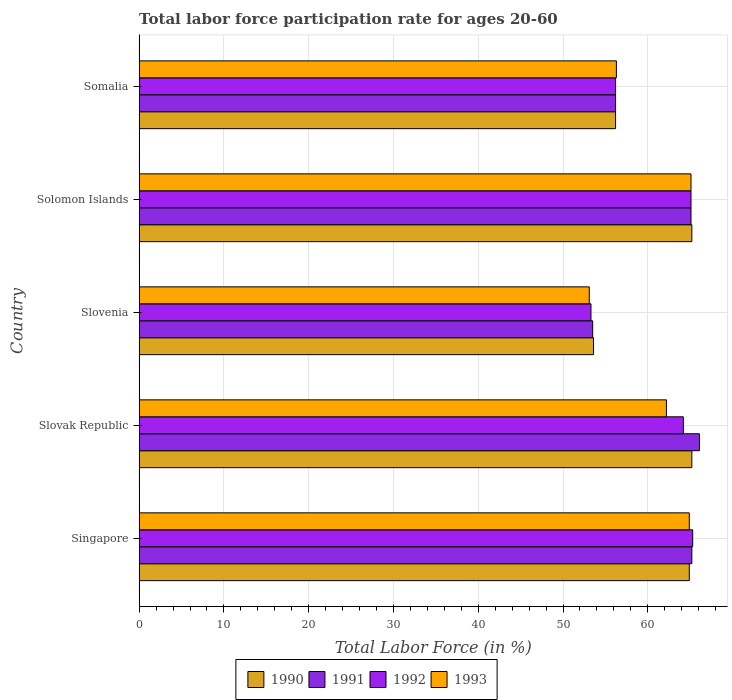How many different coloured bars are there?
Offer a terse response. 4. How many groups of bars are there?
Your answer should be compact. 5. Are the number of bars on each tick of the Y-axis equal?
Offer a terse response. Yes. How many bars are there on the 3rd tick from the top?
Ensure brevity in your answer.  4. How many bars are there on the 2nd tick from the bottom?
Make the answer very short. 4. What is the label of the 3rd group of bars from the top?
Your answer should be compact. Slovenia. What is the labor force participation rate in 1992 in Slovenia?
Ensure brevity in your answer.  53.3. Across all countries, what is the maximum labor force participation rate in 1992?
Keep it short and to the point. 65.3. Across all countries, what is the minimum labor force participation rate in 1991?
Offer a very short reply. 53.5. In which country was the labor force participation rate in 1990 maximum?
Provide a succinct answer. Slovak Republic. In which country was the labor force participation rate in 1992 minimum?
Your answer should be compact. Slovenia. What is the total labor force participation rate in 1993 in the graph?
Your answer should be compact. 301.6. What is the difference between the labor force participation rate in 1990 in Slovenia and that in Somalia?
Your response must be concise. -2.6. What is the difference between the labor force participation rate in 1990 in Slovenia and the labor force participation rate in 1993 in Singapore?
Offer a very short reply. -11.3. What is the average labor force participation rate in 1991 per country?
Your answer should be compact. 61.22. What is the difference between the labor force participation rate in 1990 and labor force participation rate in 1992 in Solomon Islands?
Give a very brief answer. 0.1. In how many countries, is the labor force participation rate in 1991 greater than 22 %?
Give a very brief answer. 5. What is the ratio of the labor force participation rate in 1991 in Slovenia to that in Somalia?
Your response must be concise. 0.95. Is the difference between the labor force participation rate in 1990 in Singapore and Slovenia greater than the difference between the labor force participation rate in 1992 in Singapore and Slovenia?
Provide a succinct answer. No. What is the difference between the highest and the second highest labor force participation rate in 1992?
Provide a succinct answer. 0.2. What is the difference between the highest and the lowest labor force participation rate in 1991?
Your response must be concise. 12.6. Is it the case that in every country, the sum of the labor force participation rate in 1993 and labor force participation rate in 1991 is greater than the labor force participation rate in 1990?
Ensure brevity in your answer.  Yes. How many bars are there?
Offer a terse response. 20. How many countries are there in the graph?
Ensure brevity in your answer.  5. Does the graph contain grids?
Keep it short and to the point. Yes. How are the legend labels stacked?
Your answer should be very brief. Horizontal. What is the title of the graph?
Offer a very short reply. Total labor force participation rate for ages 20-60. What is the label or title of the X-axis?
Offer a terse response. Total Labor Force (in %). What is the Total Labor Force (in %) in 1990 in Singapore?
Offer a very short reply. 64.9. What is the Total Labor Force (in %) of 1991 in Singapore?
Your response must be concise. 65.2. What is the Total Labor Force (in %) of 1992 in Singapore?
Provide a succinct answer. 65.3. What is the Total Labor Force (in %) of 1993 in Singapore?
Keep it short and to the point. 64.9. What is the Total Labor Force (in %) of 1990 in Slovak Republic?
Your response must be concise. 65.2. What is the Total Labor Force (in %) in 1991 in Slovak Republic?
Make the answer very short. 66.1. What is the Total Labor Force (in %) of 1992 in Slovak Republic?
Offer a terse response. 64.2. What is the Total Labor Force (in %) of 1993 in Slovak Republic?
Your answer should be very brief. 62.2. What is the Total Labor Force (in %) in 1990 in Slovenia?
Keep it short and to the point. 53.6. What is the Total Labor Force (in %) in 1991 in Slovenia?
Offer a terse response. 53.5. What is the Total Labor Force (in %) of 1992 in Slovenia?
Provide a succinct answer. 53.3. What is the Total Labor Force (in %) of 1993 in Slovenia?
Make the answer very short. 53.1. What is the Total Labor Force (in %) in 1990 in Solomon Islands?
Offer a terse response. 65.2. What is the Total Labor Force (in %) in 1991 in Solomon Islands?
Ensure brevity in your answer.  65.1. What is the Total Labor Force (in %) of 1992 in Solomon Islands?
Provide a succinct answer. 65.1. What is the Total Labor Force (in %) of 1993 in Solomon Islands?
Make the answer very short. 65.1. What is the Total Labor Force (in %) of 1990 in Somalia?
Keep it short and to the point. 56.2. What is the Total Labor Force (in %) of 1991 in Somalia?
Your answer should be very brief. 56.2. What is the Total Labor Force (in %) in 1992 in Somalia?
Your answer should be compact. 56.2. What is the Total Labor Force (in %) in 1993 in Somalia?
Your answer should be compact. 56.3. Across all countries, what is the maximum Total Labor Force (in %) in 1990?
Your response must be concise. 65.2. Across all countries, what is the maximum Total Labor Force (in %) of 1991?
Offer a very short reply. 66.1. Across all countries, what is the maximum Total Labor Force (in %) of 1992?
Your response must be concise. 65.3. Across all countries, what is the maximum Total Labor Force (in %) in 1993?
Offer a terse response. 65.1. Across all countries, what is the minimum Total Labor Force (in %) of 1990?
Provide a succinct answer. 53.6. Across all countries, what is the minimum Total Labor Force (in %) in 1991?
Your answer should be compact. 53.5. Across all countries, what is the minimum Total Labor Force (in %) in 1992?
Give a very brief answer. 53.3. Across all countries, what is the minimum Total Labor Force (in %) in 1993?
Provide a succinct answer. 53.1. What is the total Total Labor Force (in %) of 1990 in the graph?
Your answer should be very brief. 305.1. What is the total Total Labor Force (in %) of 1991 in the graph?
Ensure brevity in your answer.  306.1. What is the total Total Labor Force (in %) of 1992 in the graph?
Keep it short and to the point. 304.1. What is the total Total Labor Force (in %) of 1993 in the graph?
Your answer should be very brief. 301.6. What is the difference between the Total Labor Force (in %) of 1990 in Singapore and that in Slovak Republic?
Your answer should be very brief. -0.3. What is the difference between the Total Labor Force (in %) of 1991 in Singapore and that in Slovak Republic?
Your response must be concise. -0.9. What is the difference between the Total Labor Force (in %) in 1992 in Singapore and that in Slovak Republic?
Offer a terse response. 1.1. What is the difference between the Total Labor Force (in %) of 1991 in Singapore and that in Slovenia?
Your answer should be very brief. 11.7. What is the difference between the Total Labor Force (in %) of 1993 in Singapore and that in Slovenia?
Offer a very short reply. 11.8. What is the difference between the Total Labor Force (in %) of 1991 in Singapore and that in Solomon Islands?
Your answer should be very brief. 0.1. What is the difference between the Total Labor Force (in %) in 1993 in Singapore and that in Somalia?
Keep it short and to the point. 8.6. What is the difference between the Total Labor Force (in %) in 1991 in Slovak Republic and that in Slovenia?
Your response must be concise. 12.6. What is the difference between the Total Labor Force (in %) in 1993 in Slovak Republic and that in Slovenia?
Give a very brief answer. 9.1. What is the difference between the Total Labor Force (in %) of 1991 in Slovak Republic and that in Solomon Islands?
Your answer should be very brief. 1. What is the difference between the Total Labor Force (in %) of 1992 in Slovak Republic and that in Solomon Islands?
Keep it short and to the point. -0.9. What is the difference between the Total Labor Force (in %) of 1990 in Slovak Republic and that in Somalia?
Provide a short and direct response. 9. What is the difference between the Total Labor Force (in %) of 1992 in Slovak Republic and that in Somalia?
Offer a very short reply. 8. What is the difference between the Total Labor Force (in %) of 1990 in Slovenia and that in Solomon Islands?
Offer a very short reply. -11.6. What is the difference between the Total Labor Force (in %) of 1992 in Slovenia and that in Solomon Islands?
Ensure brevity in your answer.  -11.8. What is the difference between the Total Labor Force (in %) in 1993 in Slovenia and that in Somalia?
Your answer should be very brief. -3.2. What is the difference between the Total Labor Force (in %) in 1990 in Solomon Islands and that in Somalia?
Provide a succinct answer. 9. What is the difference between the Total Labor Force (in %) of 1991 in Solomon Islands and that in Somalia?
Provide a short and direct response. 8.9. What is the difference between the Total Labor Force (in %) of 1992 in Solomon Islands and that in Somalia?
Make the answer very short. 8.9. What is the difference between the Total Labor Force (in %) in 1991 in Singapore and the Total Labor Force (in %) in 1992 in Slovak Republic?
Offer a very short reply. 1. What is the difference between the Total Labor Force (in %) in 1991 in Singapore and the Total Labor Force (in %) in 1993 in Slovak Republic?
Offer a terse response. 3. What is the difference between the Total Labor Force (in %) of 1992 in Singapore and the Total Labor Force (in %) of 1993 in Slovak Republic?
Offer a terse response. 3.1. What is the difference between the Total Labor Force (in %) of 1990 in Singapore and the Total Labor Force (in %) of 1992 in Slovenia?
Provide a short and direct response. 11.6. What is the difference between the Total Labor Force (in %) of 1990 in Singapore and the Total Labor Force (in %) of 1993 in Slovenia?
Your answer should be very brief. 11.8. What is the difference between the Total Labor Force (in %) in 1991 in Singapore and the Total Labor Force (in %) in 1993 in Slovenia?
Give a very brief answer. 12.1. What is the difference between the Total Labor Force (in %) of 1992 in Singapore and the Total Labor Force (in %) of 1993 in Slovenia?
Your answer should be compact. 12.2. What is the difference between the Total Labor Force (in %) in 1990 in Singapore and the Total Labor Force (in %) in 1993 in Solomon Islands?
Your answer should be very brief. -0.2. What is the difference between the Total Labor Force (in %) in 1991 in Singapore and the Total Labor Force (in %) in 1993 in Solomon Islands?
Keep it short and to the point. 0.1. What is the difference between the Total Labor Force (in %) in 1992 in Singapore and the Total Labor Force (in %) in 1993 in Solomon Islands?
Make the answer very short. 0.2. What is the difference between the Total Labor Force (in %) of 1990 in Singapore and the Total Labor Force (in %) of 1991 in Somalia?
Ensure brevity in your answer.  8.7. What is the difference between the Total Labor Force (in %) of 1990 in Singapore and the Total Labor Force (in %) of 1993 in Somalia?
Your response must be concise. 8.6. What is the difference between the Total Labor Force (in %) in 1991 in Singapore and the Total Labor Force (in %) in 1992 in Somalia?
Give a very brief answer. 9. What is the difference between the Total Labor Force (in %) in 1992 in Singapore and the Total Labor Force (in %) in 1993 in Somalia?
Make the answer very short. 9. What is the difference between the Total Labor Force (in %) of 1990 in Slovak Republic and the Total Labor Force (in %) of 1992 in Slovenia?
Your answer should be compact. 11.9. What is the difference between the Total Labor Force (in %) of 1991 in Slovak Republic and the Total Labor Force (in %) of 1992 in Slovenia?
Provide a succinct answer. 12.8. What is the difference between the Total Labor Force (in %) of 1992 in Slovak Republic and the Total Labor Force (in %) of 1993 in Slovenia?
Your answer should be compact. 11.1. What is the difference between the Total Labor Force (in %) of 1990 in Slovak Republic and the Total Labor Force (in %) of 1991 in Solomon Islands?
Give a very brief answer. 0.1. What is the difference between the Total Labor Force (in %) in 1990 in Slovak Republic and the Total Labor Force (in %) in 1993 in Solomon Islands?
Offer a very short reply. 0.1. What is the difference between the Total Labor Force (in %) in 1991 in Slovak Republic and the Total Labor Force (in %) in 1993 in Solomon Islands?
Your response must be concise. 1. What is the difference between the Total Labor Force (in %) in 1992 in Slovak Republic and the Total Labor Force (in %) in 1993 in Solomon Islands?
Your answer should be very brief. -0.9. What is the difference between the Total Labor Force (in %) in 1990 in Slovak Republic and the Total Labor Force (in %) in 1992 in Somalia?
Provide a short and direct response. 9. What is the difference between the Total Labor Force (in %) in 1990 in Slovak Republic and the Total Labor Force (in %) in 1993 in Somalia?
Make the answer very short. 8.9. What is the difference between the Total Labor Force (in %) in 1991 in Slovak Republic and the Total Labor Force (in %) in 1993 in Somalia?
Give a very brief answer. 9.8. What is the difference between the Total Labor Force (in %) of 1992 in Slovak Republic and the Total Labor Force (in %) of 1993 in Somalia?
Give a very brief answer. 7.9. What is the difference between the Total Labor Force (in %) of 1990 in Slovenia and the Total Labor Force (in %) of 1992 in Solomon Islands?
Provide a succinct answer. -11.5. What is the difference between the Total Labor Force (in %) in 1992 in Slovenia and the Total Labor Force (in %) in 1993 in Solomon Islands?
Provide a short and direct response. -11.8. What is the difference between the Total Labor Force (in %) in 1990 in Slovenia and the Total Labor Force (in %) in 1993 in Somalia?
Offer a very short reply. -2.7. What is the difference between the Total Labor Force (in %) of 1991 in Slovenia and the Total Labor Force (in %) of 1993 in Somalia?
Provide a succinct answer. -2.8. What is the difference between the Total Labor Force (in %) in 1991 in Solomon Islands and the Total Labor Force (in %) in 1992 in Somalia?
Provide a short and direct response. 8.9. What is the difference between the Total Labor Force (in %) of 1992 in Solomon Islands and the Total Labor Force (in %) of 1993 in Somalia?
Make the answer very short. 8.8. What is the average Total Labor Force (in %) of 1990 per country?
Provide a succinct answer. 61.02. What is the average Total Labor Force (in %) in 1991 per country?
Your answer should be very brief. 61.22. What is the average Total Labor Force (in %) in 1992 per country?
Make the answer very short. 60.82. What is the average Total Labor Force (in %) in 1993 per country?
Give a very brief answer. 60.32. What is the difference between the Total Labor Force (in %) of 1990 and Total Labor Force (in %) of 1993 in Singapore?
Your answer should be compact. 0. What is the difference between the Total Labor Force (in %) of 1991 and Total Labor Force (in %) of 1992 in Singapore?
Your response must be concise. -0.1. What is the difference between the Total Labor Force (in %) of 1991 and Total Labor Force (in %) of 1993 in Singapore?
Offer a very short reply. 0.3. What is the difference between the Total Labor Force (in %) in 1991 and Total Labor Force (in %) in 1993 in Slovak Republic?
Provide a succinct answer. 3.9. What is the difference between the Total Labor Force (in %) of 1990 and Total Labor Force (in %) of 1991 in Slovenia?
Give a very brief answer. 0.1. What is the difference between the Total Labor Force (in %) of 1991 and Total Labor Force (in %) of 1993 in Slovenia?
Ensure brevity in your answer.  0.4. What is the difference between the Total Labor Force (in %) in 1992 and Total Labor Force (in %) in 1993 in Slovenia?
Your answer should be very brief. 0.2. What is the difference between the Total Labor Force (in %) of 1990 and Total Labor Force (in %) of 1991 in Solomon Islands?
Provide a short and direct response. 0.1. What is the difference between the Total Labor Force (in %) of 1991 and Total Labor Force (in %) of 1992 in Solomon Islands?
Offer a very short reply. 0. What is the difference between the Total Labor Force (in %) in 1992 and Total Labor Force (in %) in 1993 in Solomon Islands?
Your answer should be compact. 0. What is the difference between the Total Labor Force (in %) of 1990 and Total Labor Force (in %) of 1991 in Somalia?
Your response must be concise. 0. What is the difference between the Total Labor Force (in %) of 1990 and Total Labor Force (in %) of 1992 in Somalia?
Your answer should be very brief. 0. What is the difference between the Total Labor Force (in %) of 1990 and Total Labor Force (in %) of 1993 in Somalia?
Your response must be concise. -0.1. What is the ratio of the Total Labor Force (in %) in 1990 in Singapore to that in Slovak Republic?
Give a very brief answer. 1. What is the ratio of the Total Labor Force (in %) in 1991 in Singapore to that in Slovak Republic?
Keep it short and to the point. 0.99. What is the ratio of the Total Labor Force (in %) in 1992 in Singapore to that in Slovak Republic?
Provide a short and direct response. 1.02. What is the ratio of the Total Labor Force (in %) in 1993 in Singapore to that in Slovak Republic?
Your response must be concise. 1.04. What is the ratio of the Total Labor Force (in %) in 1990 in Singapore to that in Slovenia?
Make the answer very short. 1.21. What is the ratio of the Total Labor Force (in %) of 1991 in Singapore to that in Slovenia?
Offer a terse response. 1.22. What is the ratio of the Total Labor Force (in %) in 1992 in Singapore to that in Slovenia?
Provide a succinct answer. 1.23. What is the ratio of the Total Labor Force (in %) in 1993 in Singapore to that in Slovenia?
Give a very brief answer. 1.22. What is the ratio of the Total Labor Force (in %) of 1991 in Singapore to that in Solomon Islands?
Offer a very short reply. 1. What is the ratio of the Total Labor Force (in %) in 1992 in Singapore to that in Solomon Islands?
Give a very brief answer. 1. What is the ratio of the Total Labor Force (in %) of 1993 in Singapore to that in Solomon Islands?
Ensure brevity in your answer.  1. What is the ratio of the Total Labor Force (in %) of 1990 in Singapore to that in Somalia?
Make the answer very short. 1.15. What is the ratio of the Total Labor Force (in %) of 1991 in Singapore to that in Somalia?
Your answer should be very brief. 1.16. What is the ratio of the Total Labor Force (in %) of 1992 in Singapore to that in Somalia?
Keep it short and to the point. 1.16. What is the ratio of the Total Labor Force (in %) in 1993 in Singapore to that in Somalia?
Make the answer very short. 1.15. What is the ratio of the Total Labor Force (in %) of 1990 in Slovak Republic to that in Slovenia?
Your answer should be very brief. 1.22. What is the ratio of the Total Labor Force (in %) of 1991 in Slovak Republic to that in Slovenia?
Offer a terse response. 1.24. What is the ratio of the Total Labor Force (in %) in 1992 in Slovak Republic to that in Slovenia?
Offer a very short reply. 1.2. What is the ratio of the Total Labor Force (in %) in 1993 in Slovak Republic to that in Slovenia?
Make the answer very short. 1.17. What is the ratio of the Total Labor Force (in %) in 1990 in Slovak Republic to that in Solomon Islands?
Make the answer very short. 1. What is the ratio of the Total Labor Force (in %) in 1991 in Slovak Republic to that in Solomon Islands?
Keep it short and to the point. 1.02. What is the ratio of the Total Labor Force (in %) in 1992 in Slovak Republic to that in Solomon Islands?
Your response must be concise. 0.99. What is the ratio of the Total Labor Force (in %) of 1993 in Slovak Republic to that in Solomon Islands?
Ensure brevity in your answer.  0.96. What is the ratio of the Total Labor Force (in %) in 1990 in Slovak Republic to that in Somalia?
Offer a terse response. 1.16. What is the ratio of the Total Labor Force (in %) of 1991 in Slovak Republic to that in Somalia?
Your response must be concise. 1.18. What is the ratio of the Total Labor Force (in %) of 1992 in Slovak Republic to that in Somalia?
Make the answer very short. 1.14. What is the ratio of the Total Labor Force (in %) in 1993 in Slovak Republic to that in Somalia?
Ensure brevity in your answer.  1.1. What is the ratio of the Total Labor Force (in %) in 1990 in Slovenia to that in Solomon Islands?
Provide a succinct answer. 0.82. What is the ratio of the Total Labor Force (in %) of 1991 in Slovenia to that in Solomon Islands?
Ensure brevity in your answer.  0.82. What is the ratio of the Total Labor Force (in %) of 1992 in Slovenia to that in Solomon Islands?
Offer a very short reply. 0.82. What is the ratio of the Total Labor Force (in %) of 1993 in Slovenia to that in Solomon Islands?
Offer a terse response. 0.82. What is the ratio of the Total Labor Force (in %) in 1990 in Slovenia to that in Somalia?
Offer a very short reply. 0.95. What is the ratio of the Total Labor Force (in %) of 1992 in Slovenia to that in Somalia?
Provide a succinct answer. 0.95. What is the ratio of the Total Labor Force (in %) in 1993 in Slovenia to that in Somalia?
Your answer should be compact. 0.94. What is the ratio of the Total Labor Force (in %) in 1990 in Solomon Islands to that in Somalia?
Ensure brevity in your answer.  1.16. What is the ratio of the Total Labor Force (in %) of 1991 in Solomon Islands to that in Somalia?
Your answer should be compact. 1.16. What is the ratio of the Total Labor Force (in %) of 1992 in Solomon Islands to that in Somalia?
Provide a succinct answer. 1.16. What is the ratio of the Total Labor Force (in %) in 1993 in Solomon Islands to that in Somalia?
Keep it short and to the point. 1.16. What is the difference between the highest and the second highest Total Labor Force (in %) in 1990?
Provide a short and direct response. 0. What is the difference between the highest and the second highest Total Labor Force (in %) in 1991?
Keep it short and to the point. 0.9. What is the difference between the highest and the lowest Total Labor Force (in %) in 1991?
Your response must be concise. 12.6. What is the difference between the highest and the lowest Total Labor Force (in %) of 1992?
Provide a short and direct response. 12. What is the difference between the highest and the lowest Total Labor Force (in %) of 1993?
Make the answer very short. 12. 